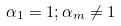<formula> <loc_0><loc_0><loc_500><loc_500>\alpha _ { 1 } = 1 ; \alpha _ { m } \ne 1</formula> 